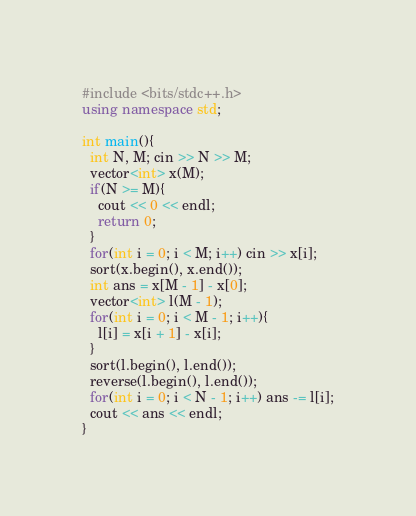Convert code to text. <code><loc_0><loc_0><loc_500><loc_500><_C++_>#include <bits/stdc++.h>
using namespace std;

int main(){
  int N, M; cin >> N >> M;
  vector<int> x(M);
  if(N >= M){
    cout << 0 << endl;
    return 0;
  }
  for(int i = 0; i < M; i++) cin >> x[i];
  sort(x.begin(), x.end());
  int ans = x[M - 1] - x[0];
  vector<int> l(M - 1);
  for(int i = 0; i < M - 1; i++){
    l[i] = x[i + 1] - x[i];
  }
  sort(l.begin(), l.end());
  reverse(l.begin(), l.end());
  for(int i = 0; i < N - 1; i++) ans -= l[i];
  cout << ans << endl;
}</code> 